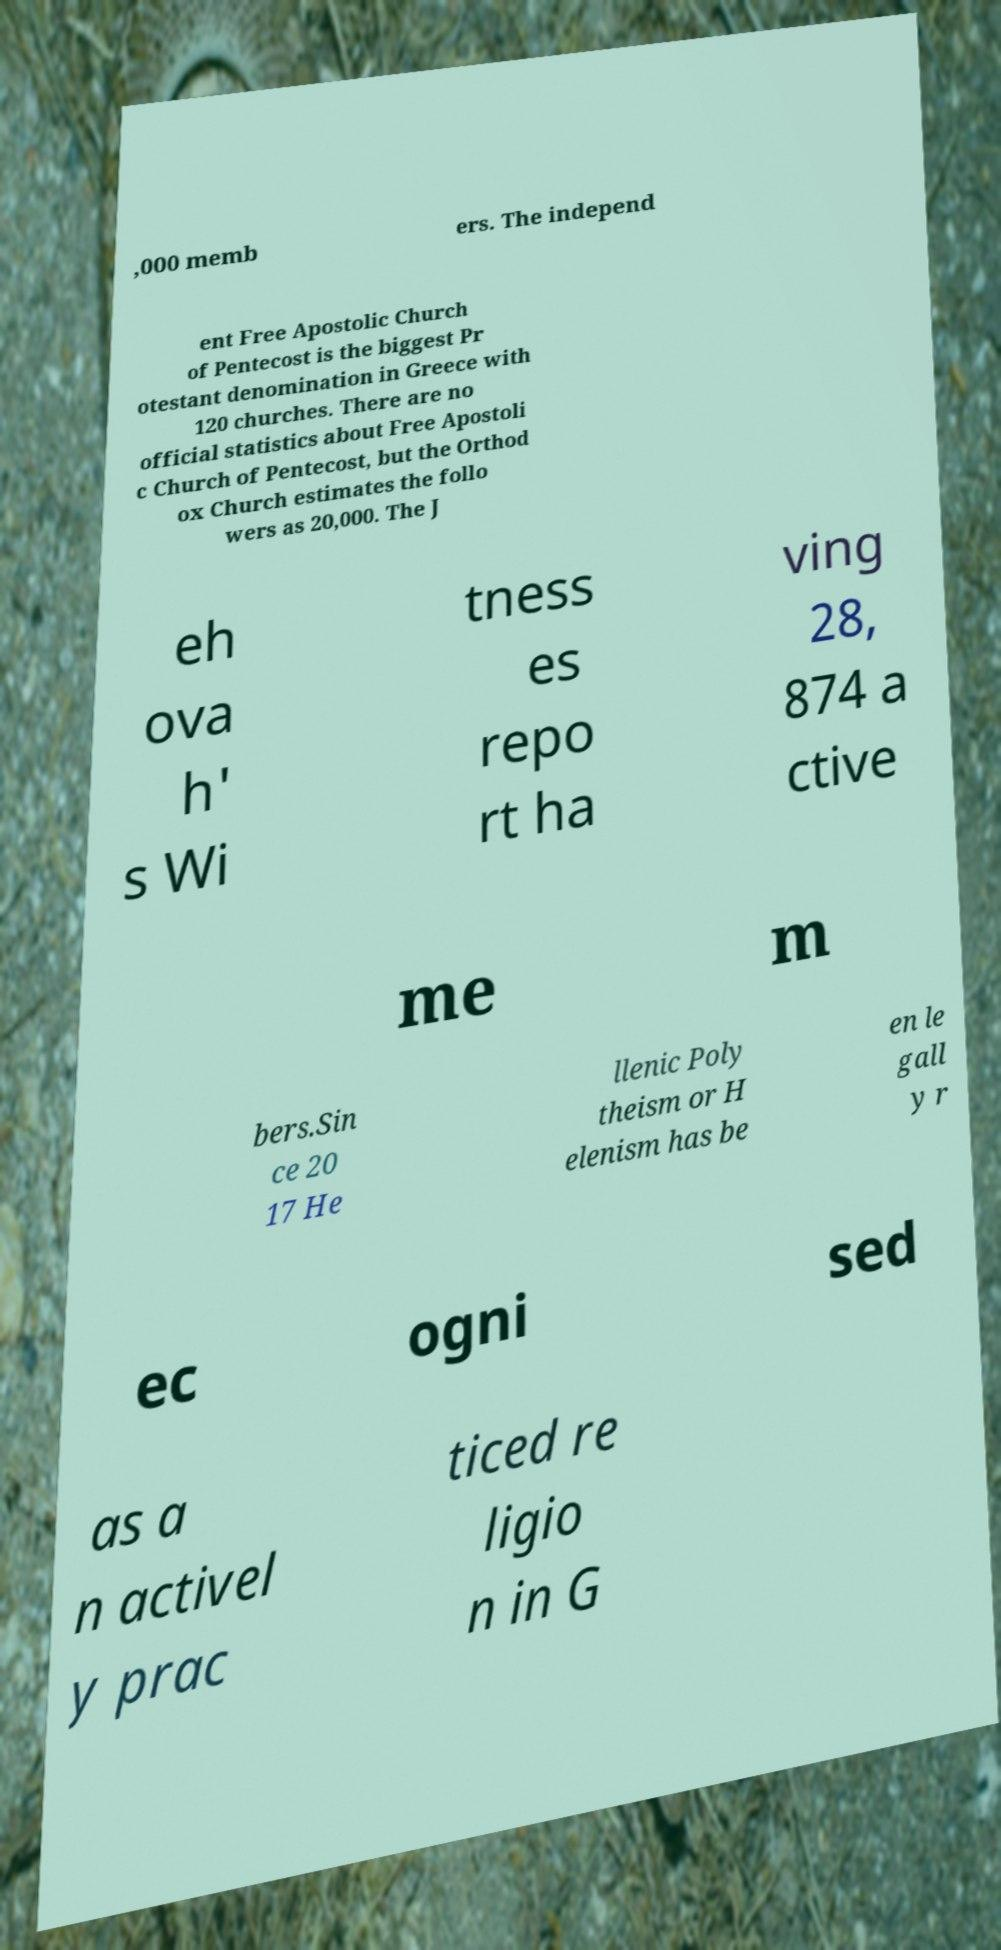Can you accurately transcribe the text from the provided image for me? ,000 memb ers. The independ ent Free Apostolic Church of Pentecost is the biggest Pr otestant denomination in Greece with 120 churches. There are no official statistics about Free Apostoli c Church of Pentecost, but the Orthod ox Church estimates the follo wers as 20,000. The J eh ova h' s Wi tness es repo rt ha ving 28, 874 a ctive me m bers.Sin ce 20 17 He llenic Poly theism or H elenism has be en le gall y r ec ogni sed as a n activel y prac ticed re ligio n in G 